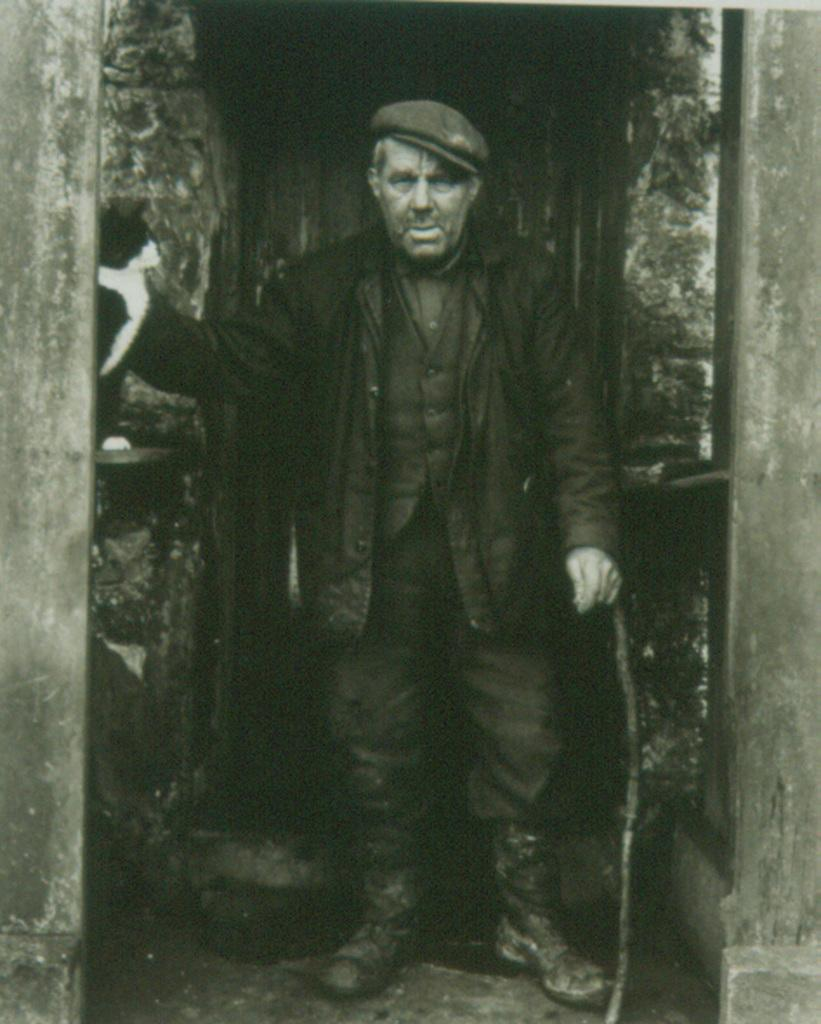Who is present in the image? There is a man in the image. What is the man doing in the image? The man is standing on the floor. Is the man combing his hair with water in the image? There is no comb, water, or any indication of hair combing in the image. 